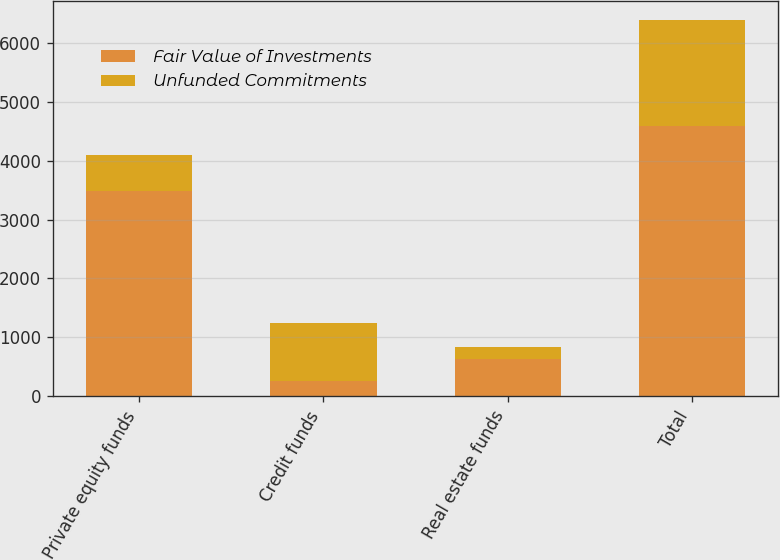Convert chart to OTSL. <chart><loc_0><loc_0><loc_500><loc_500><stacked_bar_chart><ecel><fcel>Private equity funds<fcel>Credit funds<fcel>Real estate funds<fcel>Total<nl><fcel>Fair Value of Investments<fcel>3478<fcel>266<fcel>629<fcel>4596<nl><fcel>Unfunded Commitments<fcel>614<fcel>985<fcel>201<fcel>1800<nl></chart> 